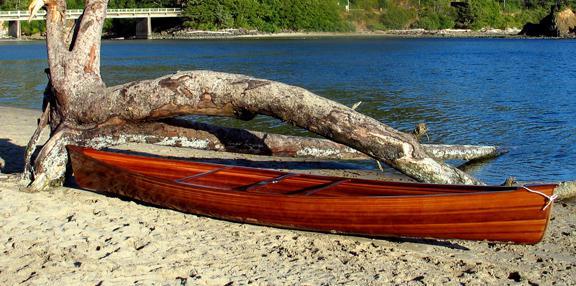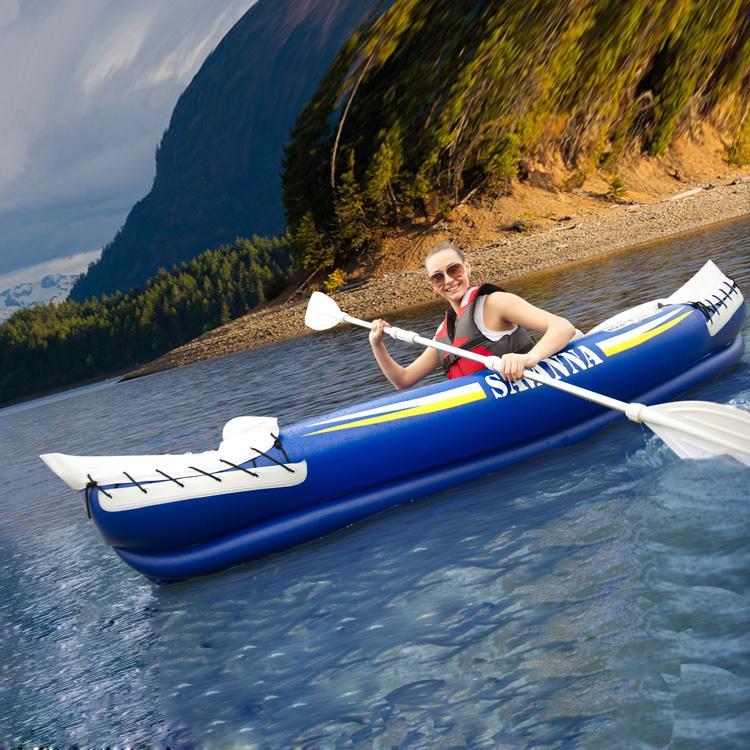The first image is the image on the left, the second image is the image on the right. Analyze the images presented: Is the assertion "In one image, there is a white canoe resting slightly on its side on a large rocky area in the middle of a body of water" valid? Answer yes or no. No. 